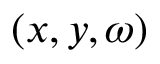Convert formula to latex. <formula><loc_0><loc_0><loc_500><loc_500>( x , y , \omega )</formula> 